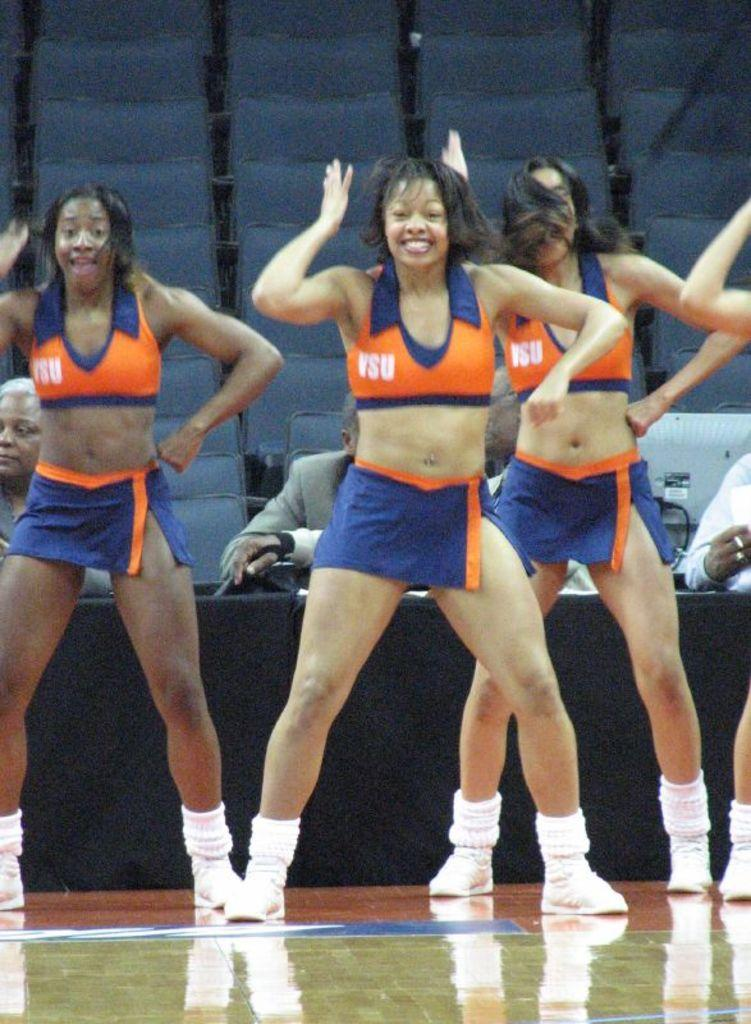Provide a one-sentence caption for the provided image. Several cheerleaders wearing uniforms inscripted with VSU are performing. 